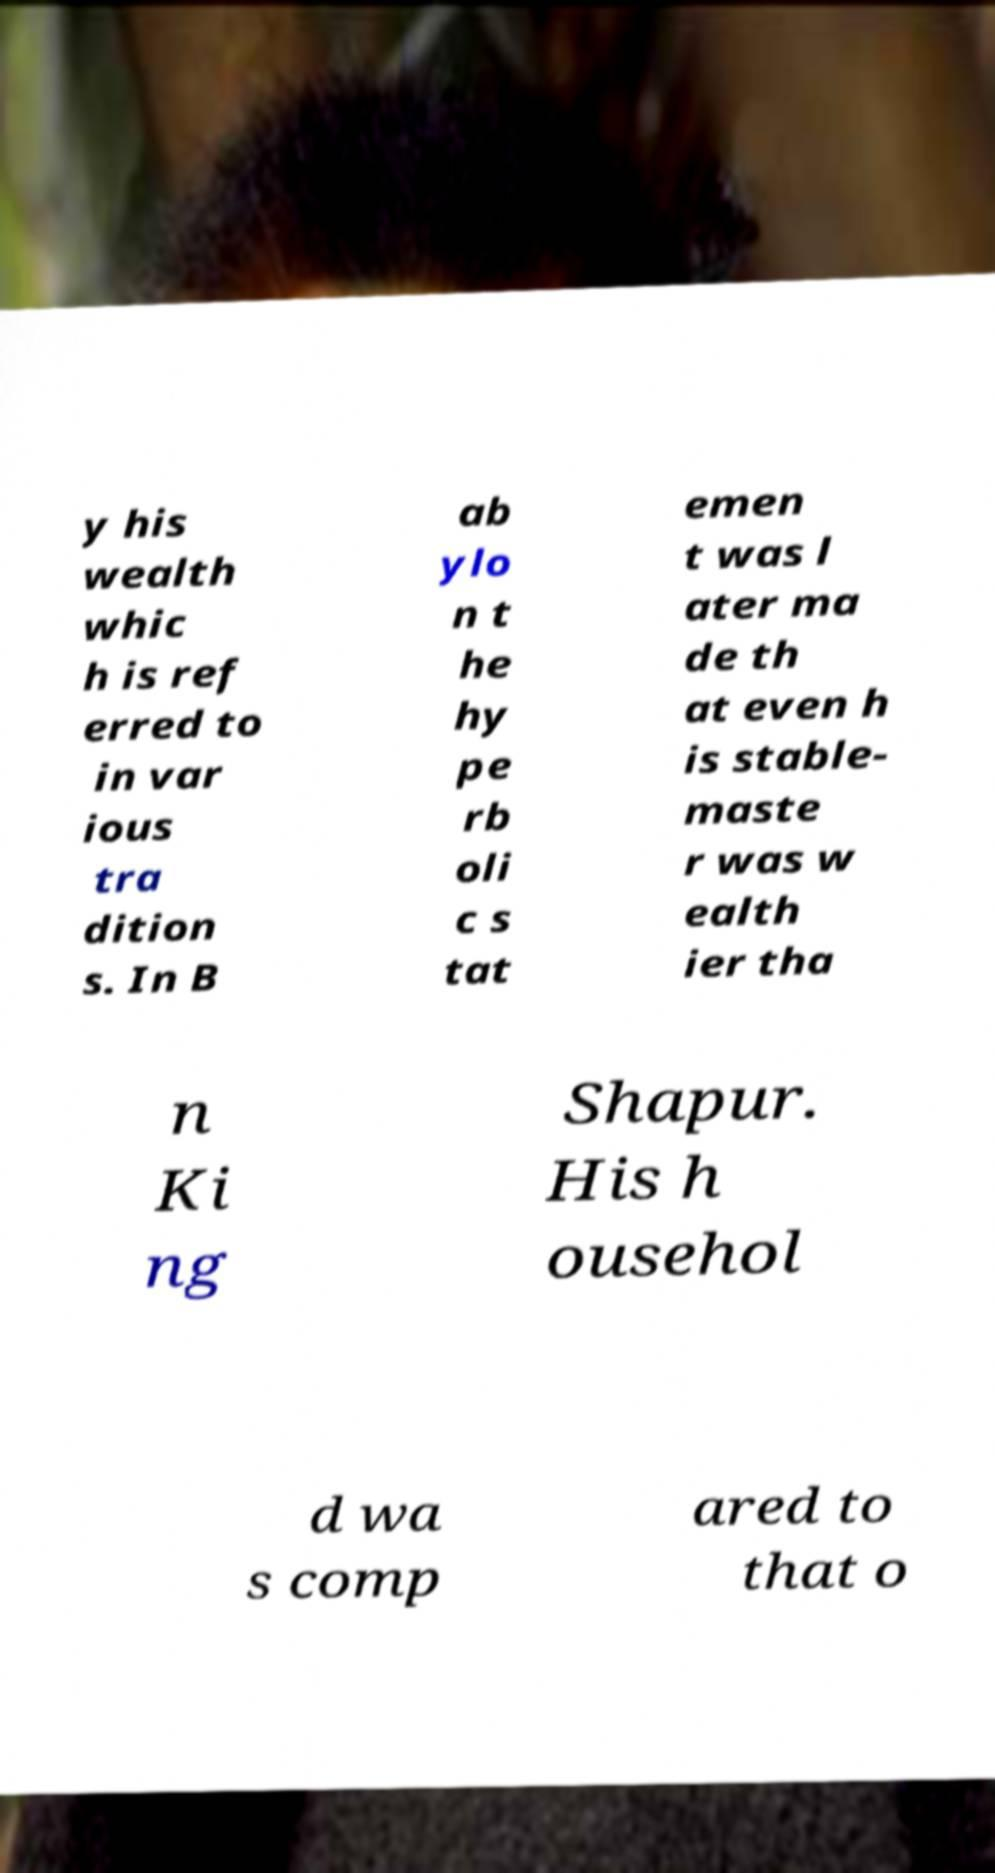There's text embedded in this image that I need extracted. Can you transcribe it verbatim? y his wealth whic h is ref erred to in var ious tra dition s. In B ab ylo n t he hy pe rb oli c s tat emen t was l ater ma de th at even h is stable- maste r was w ealth ier tha n Ki ng Shapur. His h ousehol d wa s comp ared to that o 